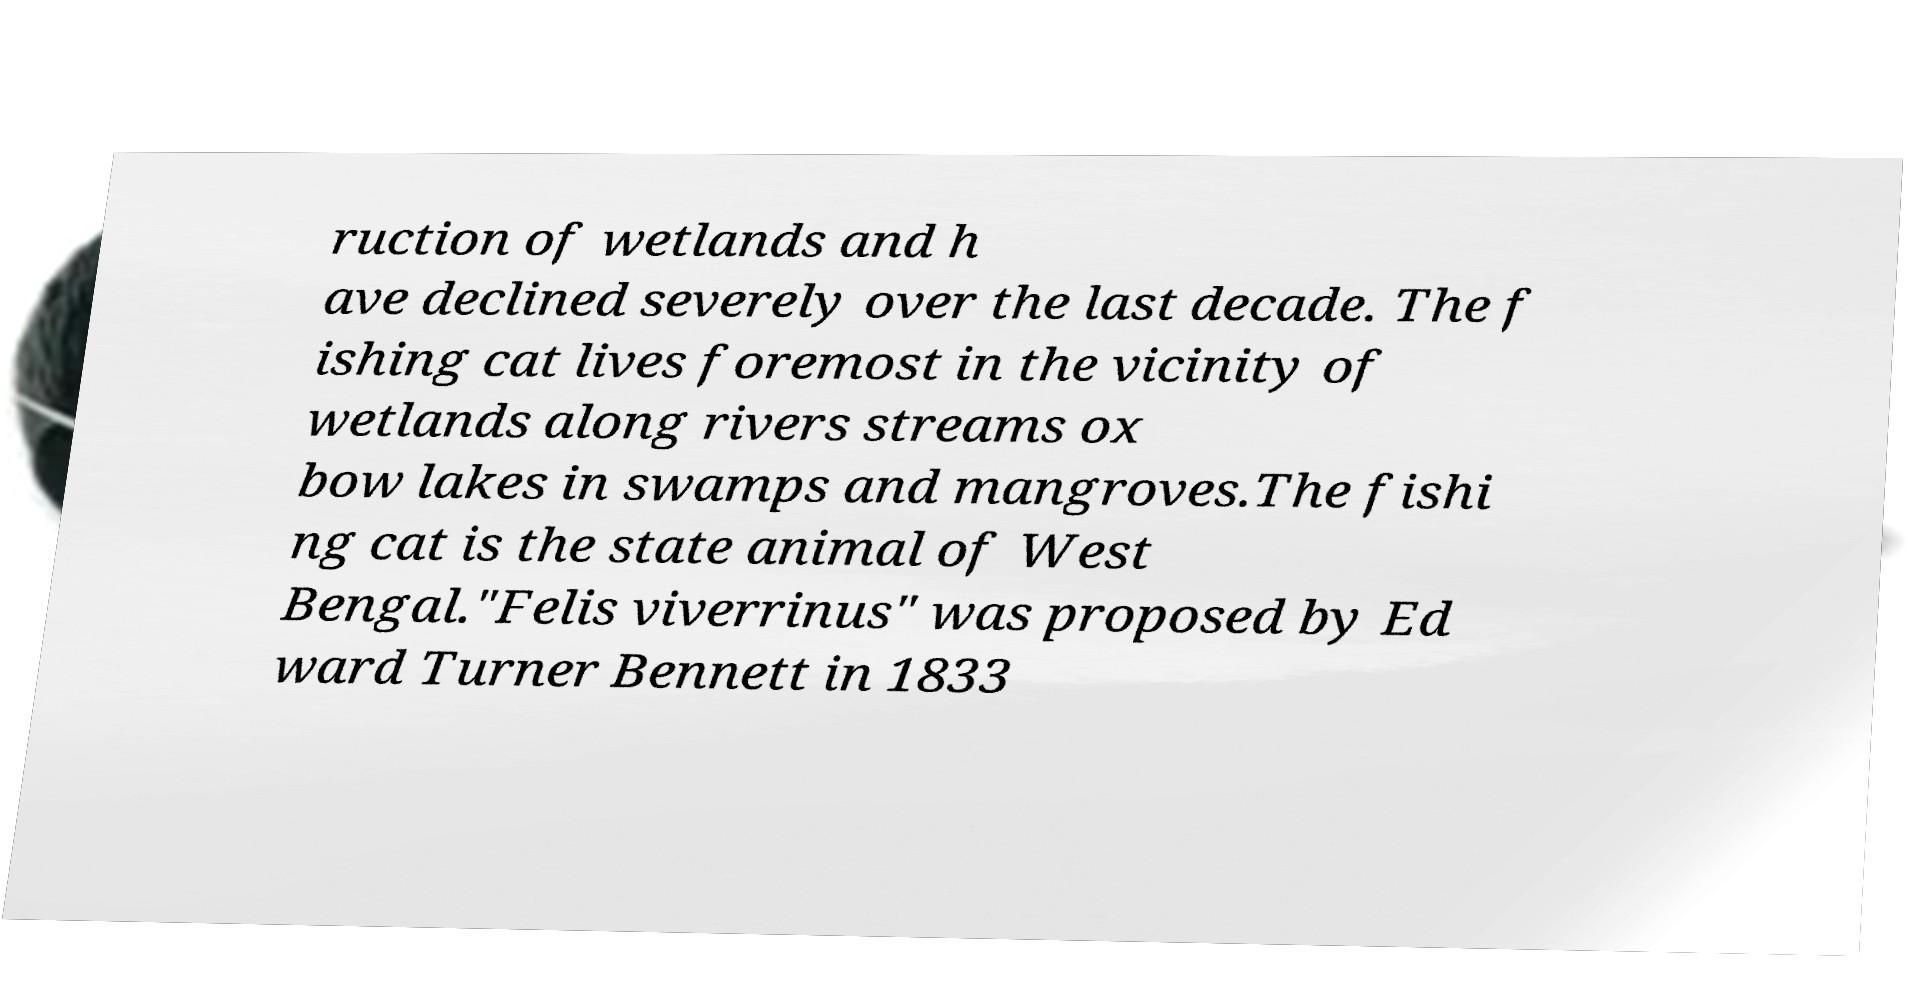I need the written content from this picture converted into text. Can you do that? ruction of wetlands and h ave declined severely over the last decade. The f ishing cat lives foremost in the vicinity of wetlands along rivers streams ox bow lakes in swamps and mangroves.The fishi ng cat is the state animal of West Bengal."Felis viverrinus" was proposed by Ed ward Turner Bennett in 1833 